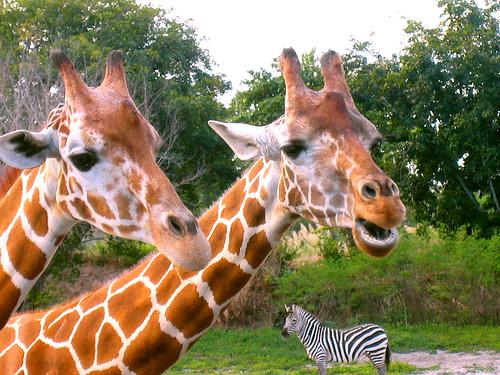What is in front of the zebra? Please explain your reasoning. giraffe. There is a giraffe at the front. 